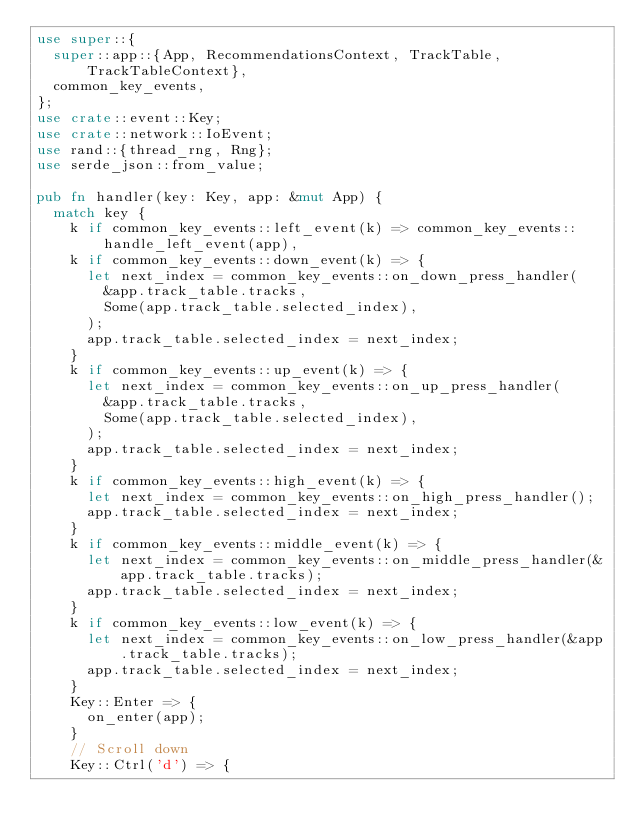<code> <loc_0><loc_0><loc_500><loc_500><_Rust_>use super::{
  super::app::{App, RecommendationsContext, TrackTable, TrackTableContext},
  common_key_events,
};
use crate::event::Key;
use crate::network::IoEvent;
use rand::{thread_rng, Rng};
use serde_json::from_value;

pub fn handler(key: Key, app: &mut App) {
  match key {
    k if common_key_events::left_event(k) => common_key_events::handle_left_event(app),
    k if common_key_events::down_event(k) => {
      let next_index = common_key_events::on_down_press_handler(
        &app.track_table.tracks,
        Some(app.track_table.selected_index),
      );
      app.track_table.selected_index = next_index;
    }
    k if common_key_events::up_event(k) => {
      let next_index = common_key_events::on_up_press_handler(
        &app.track_table.tracks,
        Some(app.track_table.selected_index),
      );
      app.track_table.selected_index = next_index;
    }
    k if common_key_events::high_event(k) => {
      let next_index = common_key_events::on_high_press_handler();
      app.track_table.selected_index = next_index;
    }
    k if common_key_events::middle_event(k) => {
      let next_index = common_key_events::on_middle_press_handler(&app.track_table.tracks);
      app.track_table.selected_index = next_index;
    }
    k if common_key_events::low_event(k) => {
      let next_index = common_key_events::on_low_press_handler(&app.track_table.tracks);
      app.track_table.selected_index = next_index;
    }
    Key::Enter => {
      on_enter(app);
    }
    // Scroll down
    Key::Ctrl('d') => {</code> 